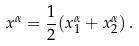<formula> <loc_0><loc_0><loc_500><loc_500>x ^ { \alpha } = \frac { 1 } { 2 } ( x ^ { \alpha } _ { 1 } + x ^ { \alpha } _ { 2 } ) \, .</formula> 